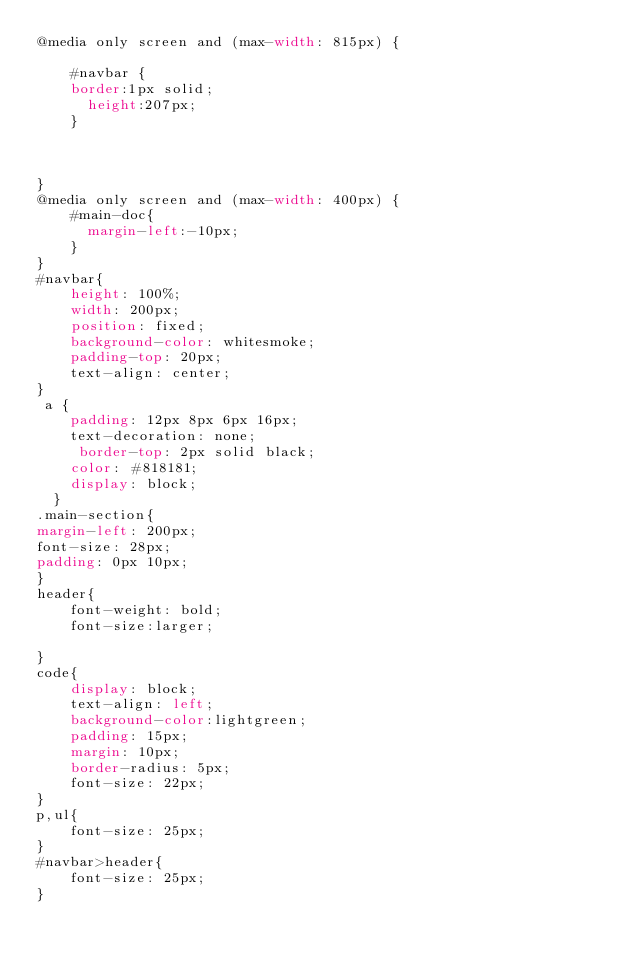<code> <loc_0><loc_0><loc_500><loc_500><_CSS_>@media only screen and (max-width: 815px) {
      
    #navbar {
    border:1px solid;
      height:207px;
    }

 

}
@media only screen and (max-width: 400px) {
    #main-doc{
      margin-left:-10px;
    }
}
#navbar{
    height: 100%;
    width: 200px;
    position: fixed;
    background-color: whitesmoke;
    padding-top: 20px;
    text-align: center;
}
 a {
    padding: 12px 8px 6px 16px;
    text-decoration: none;
     border-top: 2px solid black;
    color: #818181;
    display: block;
  }
.main-section{
margin-left: 200px;
font-size: 28px;
padding: 0px 10px;
}
header{
    font-weight: bold;
    font-size:larger;

}
code{
    display: block;
    text-align: left;
    background-color:lightgreen;
    padding: 15px;
    margin: 10px;
    border-radius: 5px;
    font-size: 22px;
}
p,ul{
    font-size: 25px;
}
#navbar>header{
    font-size: 25px;
}




</code> 